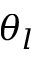Convert formula to latex. <formula><loc_0><loc_0><loc_500><loc_500>\theta _ { l }</formula> 